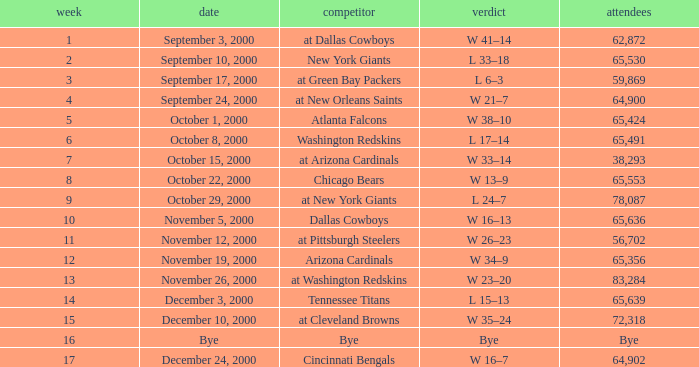Parse the table in full. {'header': ['week', 'date', 'competitor', 'verdict', 'attendees'], 'rows': [['1', 'September 3, 2000', 'at Dallas Cowboys', 'W 41–14', '62,872'], ['2', 'September 10, 2000', 'New York Giants', 'L 33–18', '65,530'], ['3', 'September 17, 2000', 'at Green Bay Packers', 'L 6–3', '59,869'], ['4', 'September 24, 2000', 'at New Orleans Saints', 'W 21–7', '64,900'], ['5', 'October 1, 2000', 'Atlanta Falcons', 'W 38–10', '65,424'], ['6', 'October 8, 2000', 'Washington Redskins', 'L 17–14', '65,491'], ['7', 'October 15, 2000', 'at Arizona Cardinals', 'W 33–14', '38,293'], ['8', 'October 22, 2000', 'Chicago Bears', 'W 13–9', '65,553'], ['9', 'October 29, 2000', 'at New York Giants', 'L 24–7', '78,087'], ['10', 'November 5, 2000', 'Dallas Cowboys', 'W 16–13', '65,636'], ['11', 'November 12, 2000', 'at Pittsburgh Steelers', 'W 26–23', '56,702'], ['12', 'November 19, 2000', 'Arizona Cardinals', 'W 34–9', '65,356'], ['13', 'November 26, 2000', 'at Washington Redskins', 'W 23–20', '83,284'], ['14', 'December 3, 2000', 'Tennessee Titans', 'L 15–13', '65,639'], ['15', 'December 10, 2000', 'at Cleveland Browns', 'W 35–24', '72,318'], ['16', 'Bye', 'Bye', 'Bye', 'Bye'], ['17', 'December 24, 2000', 'Cincinnati Bengals', 'W 16–7', '64,902']]} What was the attendance when the Cincinnati Bengals were the opponents? 64902.0. 